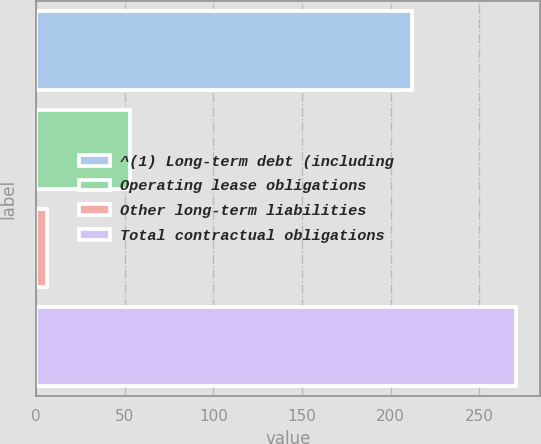Convert chart to OTSL. <chart><loc_0><loc_0><loc_500><loc_500><bar_chart><fcel>^(1) Long-term debt (including<fcel>Operating lease obligations<fcel>Other long-term liabilities<fcel>Total contractual obligations<nl><fcel>212<fcel>53<fcel>6<fcel>271<nl></chart> 